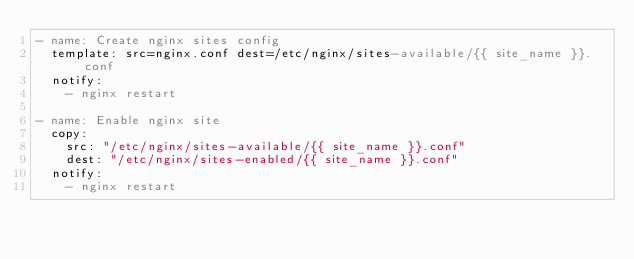<code> <loc_0><loc_0><loc_500><loc_500><_YAML_>- name: Create nginx sites config
  template: src=nginx.conf dest=/etc/nginx/sites-available/{{ site_name }}.conf
  notify:
    - nginx restart

- name: Enable nginx site
  copy:
    src: "/etc/nginx/sites-available/{{ site_name }}.conf"
    dest: "/etc/nginx/sites-enabled/{{ site_name }}.conf"
  notify:
    - nginx restart
</code> 